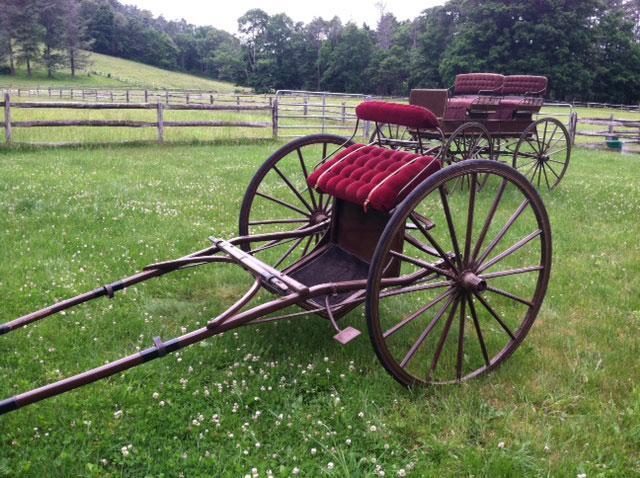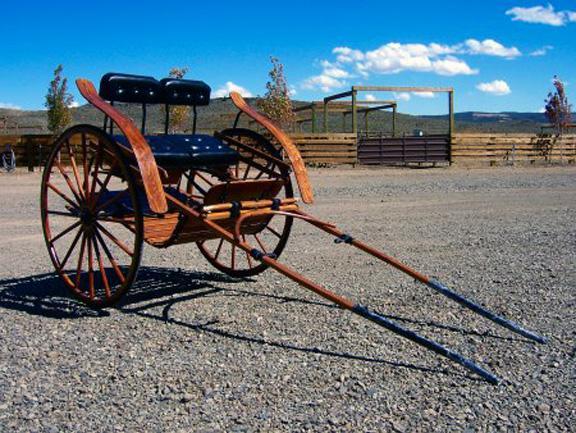The first image is the image on the left, the second image is the image on the right. Assess this claim about the two images: "At least one carriage is being pulled by a horse.". Correct or not? Answer yes or no. No. The first image is the image on the left, the second image is the image on the right. Assess this claim about the two images: "At least one buggy is attached to a horse.". Correct or not? Answer yes or no. No. 